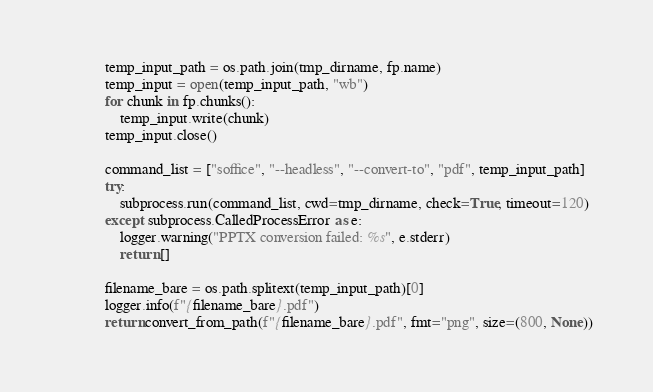<code> <loc_0><loc_0><loc_500><loc_500><_Python_>            temp_input_path = os.path.join(tmp_dirname, fp.name)
            temp_input = open(temp_input_path, "wb")
            for chunk in fp.chunks():
                temp_input.write(chunk)
            temp_input.close()

            command_list = ["soffice", "--headless", "--convert-to", "pdf", temp_input_path]
            try:
                subprocess.run(command_list, cwd=tmp_dirname, check=True, timeout=120)
            except subprocess.CalledProcessError as e:
                logger.warning("PPTX conversion failed: %s", e.stderr)
                return []

            filename_bare = os.path.splitext(temp_input_path)[0]
            logger.info(f"{filename_bare}.pdf")
            return convert_from_path(f"{filename_bare}.pdf", fmt="png", size=(800, None))
</code> 